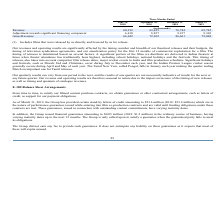From Eros International Plc's financial document, What is taken into account while releasing films? The document contains multiple relevant values: school holidays, national holidays, the festivals, competitor film release dates, major cricket events in India, film production schedules.. From the document: "including school holidays, national holidays and the festivals. This timing of releases also takes into account competitor film release dates, major c..." Also, What was the revenue in three months ended June 2018? According to the financial document, 60,212 (in thousands). The relevant text states: "Revenue 60,212 63,425 76,744 69,745..." Also, What is the adjustment towards significant financing component in three months ended June 2018? According to the financial document, 6,410 (in thousands). The relevant text states: "djustment towards significant financing component 6,410 8,837 9,917 9,303..." Additionally, What are the Three months ended periods that have gross revenue exceeding $70,000 thousand? The document contains multiple relevant values: September 30, 2018, December 31, 2018, March 31, 2019. From the document: "Three Months Ended June 30, 2018 September 30, 2018 December 31, 2018 March 31, 2019 une 30, 2018 September 30, 2018 December 31, 2018 March 31, 2019 ..." Also, can you calculate: What is the average quarterly Adjustment towards significant financing component for  Three Months Ended June 30 2018 to march 31, 2019? To answer this question, I need to perform calculations using the financial data. The calculation is: (6,410 + 8,837 + 9,917 + 9,303) / 4, which equals 8616.75 (in thousands). This is based on the information: "wards significant financing component 6,410 8,837 9,917 9,303 djustment towards significant financing component 6,410 8,837 9,917 9,303 significant financing component 6,410 8,837 9,917 9,303 ent towa..." The key data points involved are: 6,410, 8,837, 9,303. Also, can you calculate: What is the percentage increase / (decrease) in the Gross Revenue from Three Months Ended  December 2018 to March 2019? To answer this question, I need to perform calculations using the financial data. The calculation is: 79,048 / 86,661 - 1, which equals -8.78 (percentage). This is based on the information: "Gross Revenue 66,622 72,262 86,661 79,048 Gross Revenue 66,622 72,262 86,661 79,048..." The key data points involved are: 79,048, 86,661. 